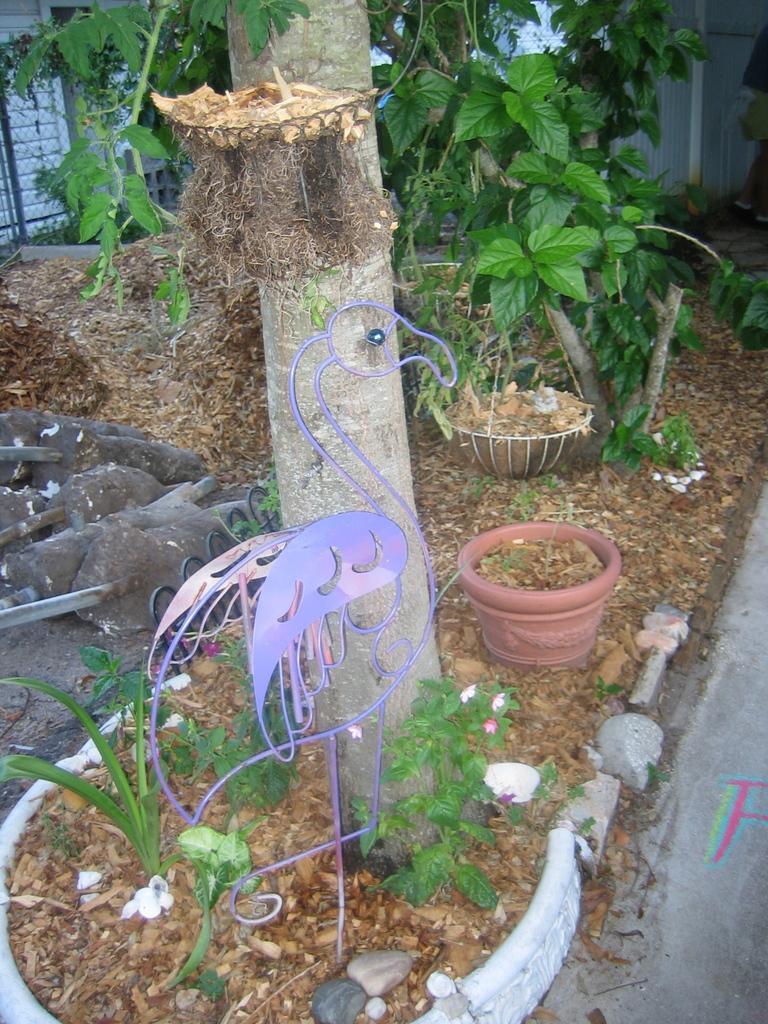Could you give a brief overview of what you see in this image? In this picture I can see there is a tree and there are few plants, soil, dry leaves and there is a purple metal frame of a bird. In the backdrop there are few other plants and there is a fence and there is a building. 